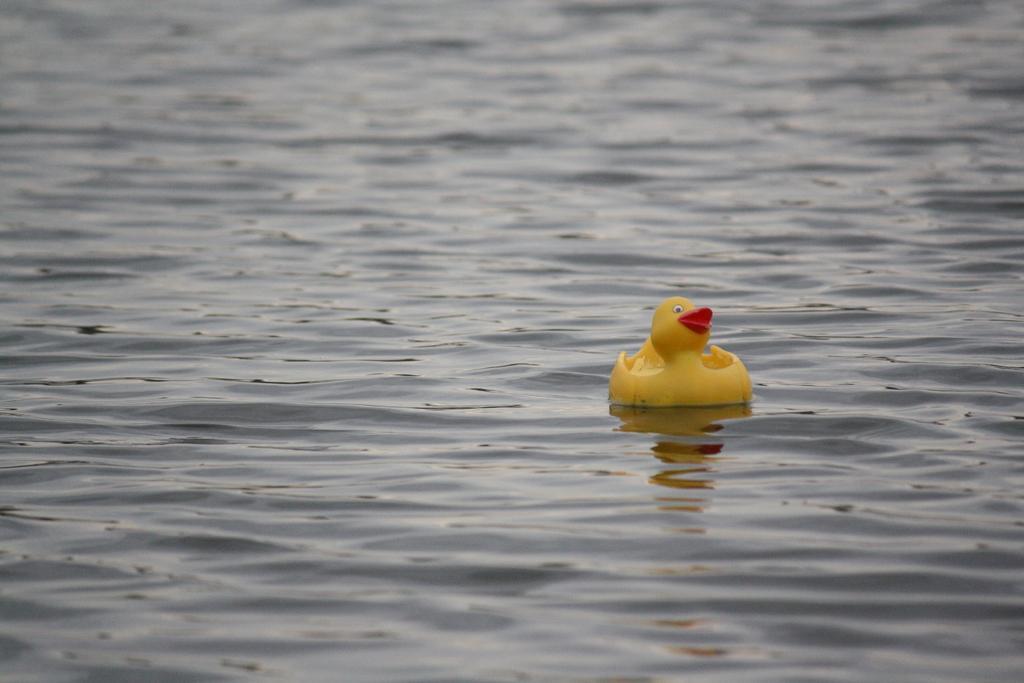Can you describe this image briefly? In this image there is a toy on the surface of the water having ripples. 